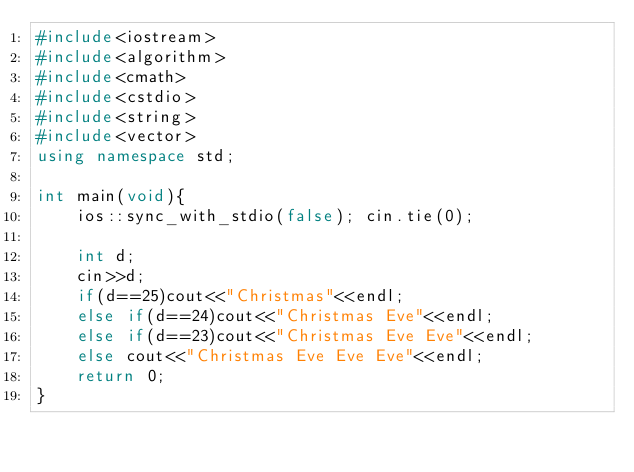<code> <loc_0><loc_0><loc_500><loc_500><_C++_>#include<iostream>
#include<algorithm>
#include<cmath>
#include<cstdio>
#include<string>
#include<vector>
using namespace std;

int main(void){
	ios::sync_with_stdio(false); cin.tie(0);
	
	int d;
	cin>>d;
	if(d==25)cout<<"Christmas"<<endl;
	else if(d==24)cout<<"Christmas Eve"<<endl;
	else if(d==23)cout<<"Christmas Eve Eve"<<endl;
	else cout<<"Christmas Eve Eve Eve"<<endl;
	return 0;
}</code> 